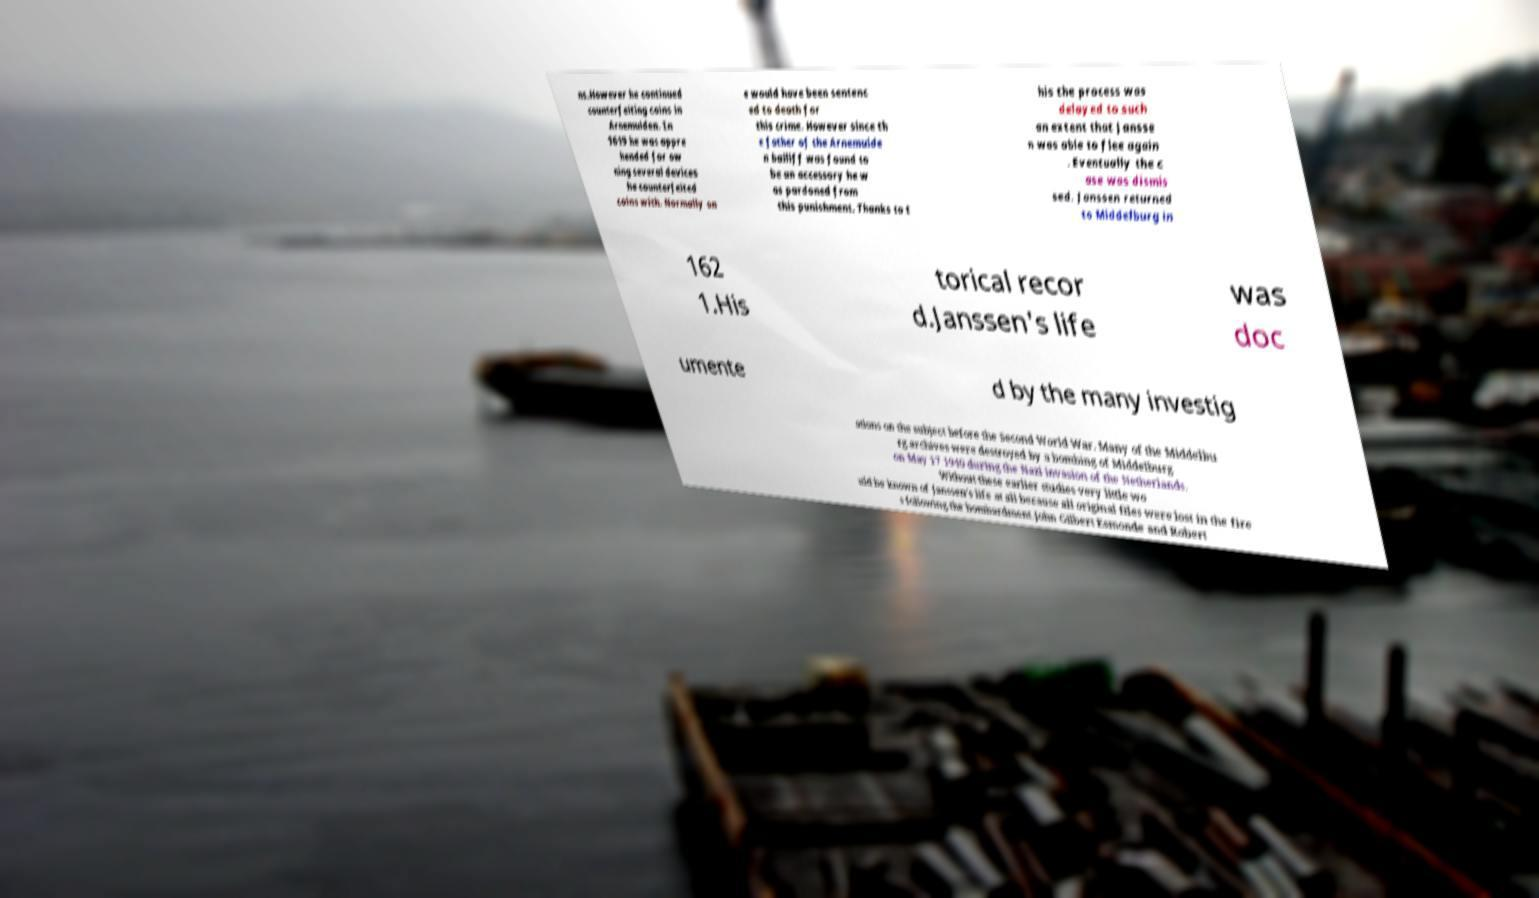I need the written content from this picture converted into text. Can you do that? ns.However he continued counterfeiting coins in Arnemuiden. In 1619 he was appre hended for ow ning several devices he counterfeited coins with. Normally on e would have been sentenc ed to death for this crime. However since th e father of the Arnemuide n bailiff was found to be an accessory he w as pardoned from this punishment. Thanks to t his the process was delayed to such an extent that Jansse n was able to flee again . Eventually the c ase was dismis sed. Janssen returned to Middelburg in 162 1.His torical recor d.Janssen's life was doc umente d by the many investig ations on the subject before the Second World War. Many of the Middelbu rg archives were destroyed by a bombing of Middelburg on May 17 1940 during the Nazi invasion of the Netherlands. Without these earlier studies very little wo uld be known of Janssen's life at all because all original files were lost in the fire s following the bombardment.John Gilbert Esmonde and Robert 